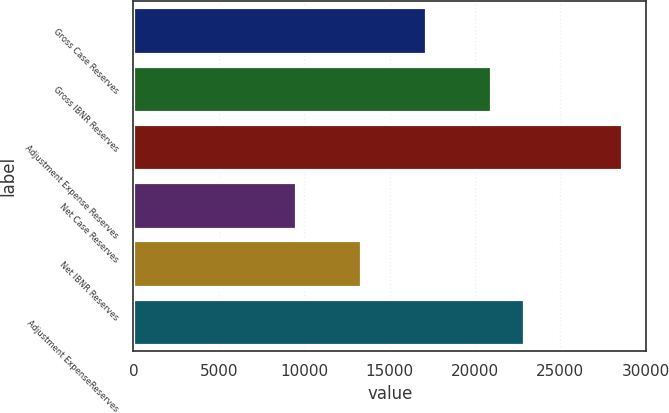Convert chart to OTSL. <chart><loc_0><loc_0><loc_500><loc_500><bar_chart><fcel>Gross Case Reserves<fcel>Gross IBNR Reserves<fcel>Adjustment Expense Reserves<fcel>Net Case Reserves<fcel>Net IBNR Reserves<fcel>Adjustment ExpenseReserves<nl><fcel>17155<fcel>20966<fcel>28588<fcel>9533<fcel>13344<fcel>22871.5<nl></chart> 